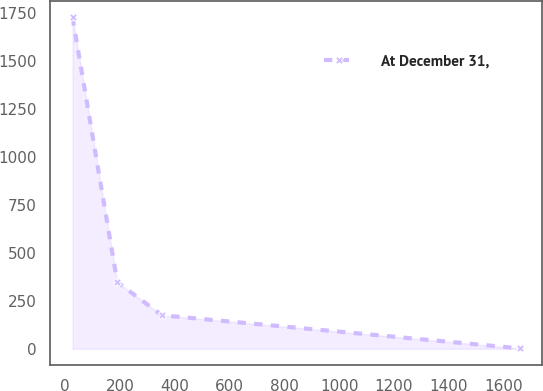Convert chart to OTSL. <chart><loc_0><loc_0><loc_500><loc_500><line_chart><ecel><fcel>At December 31,<nl><fcel>27.54<fcel>1728.99<nl><fcel>190.71<fcel>347.58<nl><fcel>353.88<fcel>174.9<nl><fcel>1659.26<fcel>2.22<nl></chart> 